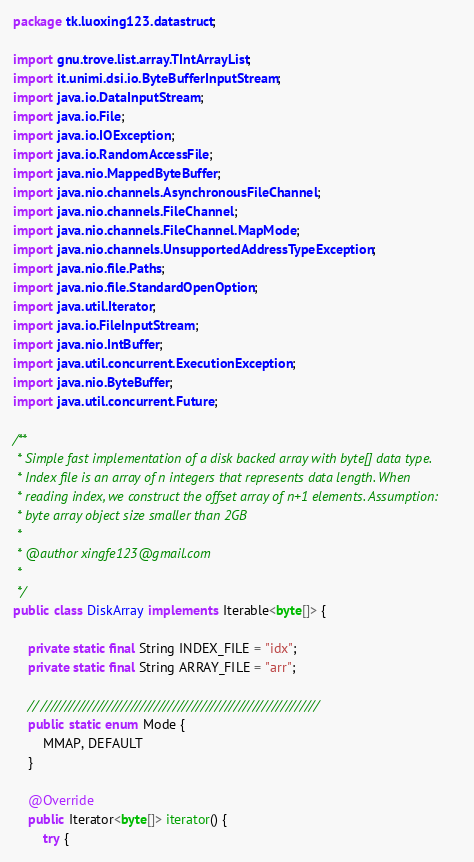<code> <loc_0><loc_0><loc_500><loc_500><_Java_>package tk.luoxing123.datastruct;

import gnu.trove.list.array.TIntArrayList;
import it.unimi.dsi.io.ByteBufferInputStream;
import java.io.DataInputStream;
import java.io.File;
import java.io.IOException;
import java.io.RandomAccessFile;
import java.nio.MappedByteBuffer;
import java.nio.channels.AsynchronousFileChannel;
import java.nio.channels.FileChannel;
import java.nio.channels.FileChannel.MapMode;
import java.nio.channels.UnsupportedAddressTypeException;
import java.nio.file.Paths;
import java.nio.file.StandardOpenOption;
import java.util.Iterator;
import java.io.FileInputStream;
import java.nio.IntBuffer;
import java.util.concurrent.ExecutionException;
import java.nio.ByteBuffer;
import java.util.concurrent.Future;

/**
 * Simple fast implementation of a disk backed array with byte[] data type.
 * Index file is an array of n integers that represents data length. When
 * reading index, we construct the offset array of n+1 elements. Assumption:
 * byte array object size smaller than 2GB
 * 
 * @author xingfe123@gmail.com
 *
 */
public class DiskArray implements Iterable<byte[]> {

	private static final String INDEX_FILE = "idx";
	private static final String ARRAY_FILE = "arr";

	// ///////////////////////////////////////////////////////////
	public static enum Mode {
		MMAP, DEFAULT
	}

	@Override
	public Iterator<byte[]> iterator() {
		try {</code> 